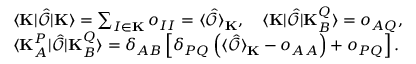<formula> <loc_0><loc_0><loc_500><loc_500>\begin{array} { r l } & { \langle K | \hat { \mathcal { O } } | K \rangle = \sum _ { I \in K } o _ { I I } = \langle \hat { \mathcal { O } } \rangle _ { K } , \quad \langle K | \hat { \mathcal { O } } | K _ { B } ^ { Q } \rangle = o _ { A Q } , } \\ & { \langle K _ { A } ^ { P } | \hat { \mathcal { O } } | K _ { B } ^ { Q } \rangle = \delta _ { A B } \left [ \delta _ { P Q } \left ( \langle \hat { \mathcal { O } } \rangle _ { K } - o _ { A A } \right ) + o _ { P Q } \right ] . } \end{array}</formula> 